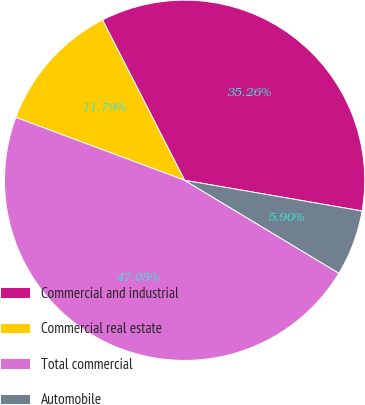Convert chart to OTSL. <chart><loc_0><loc_0><loc_500><loc_500><pie_chart><fcel>Commercial and industrial<fcel>Commercial real estate<fcel>Total commercial<fcel>Automobile<nl><fcel>35.26%<fcel>11.79%<fcel>47.05%<fcel>5.9%<nl></chart> 